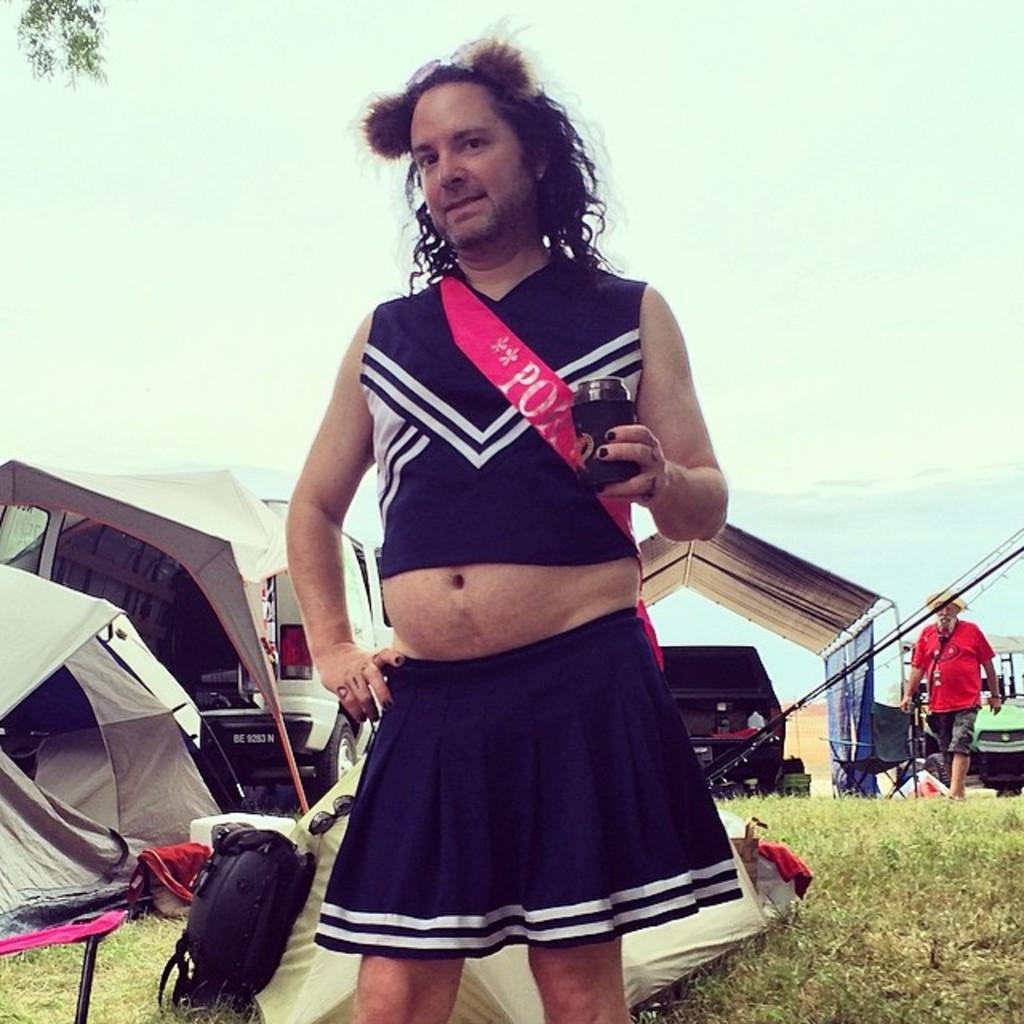<image>
Provide a brief description of the given image. a man with the letters PO on his cheerleading uniform 